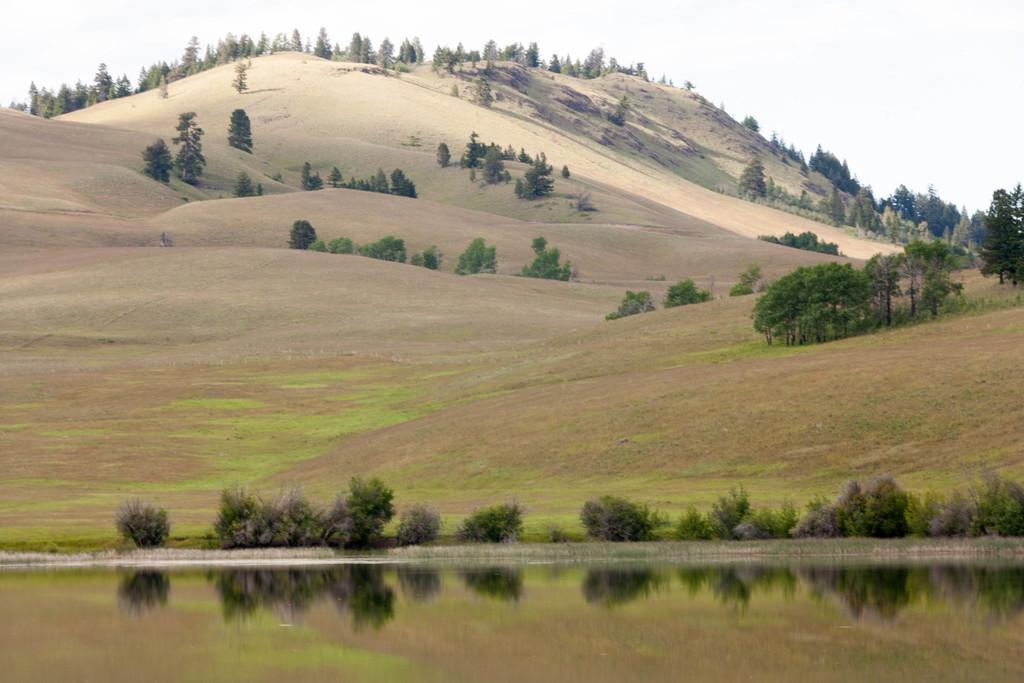What type of natural feature is present in the image? There is a river in the image. What other natural elements can be seen in the image? There are trees and mountains in the image. What is visible in the background of the image? The sky is visible in the image. What type of dress is the boy wearing in the alley in the image? There is no boy or alley present in the image; it features a river, trees, mountains, and the sky. 